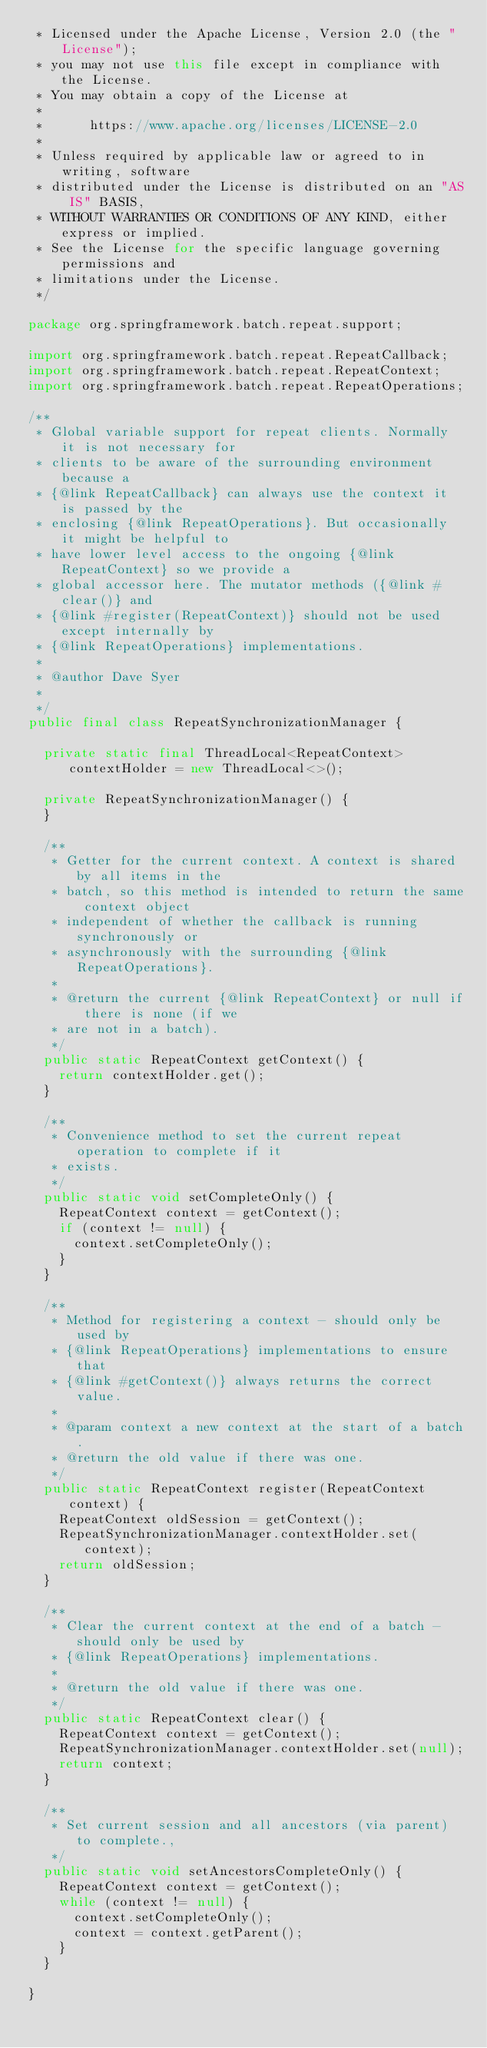Convert code to text. <code><loc_0><loc_0><loc_500><loc_500><_Java_> * Licensed under the Apache License, Version 2.0 (the "License");
 * you may not use this file except in compliance with the License.
 * You may obtain a copy of the License at
 *
 *      https://www.apache.org/licenses/LICENSE-2.0
 *
 * Unless required by applicable law or agreed to in writing, software
 * distributed under the License is distributed on an "AS IS" BASIS,
 * WITHOUT WARRANTIES OR CONDITIONS OF ANY KIND, either express or implied.
 * See the License for the specific language governing permissions and
 * limitations under the License.
 */

package org.springframework.batch.repeat.support;

import org.springframework.batch.repeat.RepeatCallback;
import org.springframework.batch.repeat.RepeatContext;
import org.springframework.batch.repeat.RepeatOperations;

/**
 * Global variable support for repeat clients. Normally it is not necessary for
 * clients to be aware of the surrounding environment because a
 * {@link RepeatCallback} can always use the context it is passed by the
 * enclosing {@link RepeatOperations}. But occasionally it might be helpful to
 * have lower level access to the ongoing {@link RepeatContext} so we provide a
 * global accessor here. The mutator methods ({@link #clear()} and
 * {@link #register(RepeatContext)} should not be used except internally by
 * {@link RepeatOperations} implementations.
 * 
 * @author Dave Syer
 * 
 */
public final class RepeatSynchronizationManager {

	private static final ThreadLocal<RepeatContext> contextHolder = new ThreadLocal<>();

	private RepeatSynchronizationManager() {
	}

	/**
	 * Getter for the current context. A context is shared by all items in the
	 * batch, so this method is intended to return the same context object
	 * independent of whether the callback is running synchronously or
	 * asynchronously with the surrounding {@link RepeatOperations}.
	 * 
	 * @return the current {@link RepeatContext} or null if there is none (if we
	 * are not in a batch).
	 */
	public static RepeatContext getContext() {
		return contextHolder.get();
	}

	/**
	 * Convenience method to set the current repeat operation to complete if it
	 * exists.
	 */
	public static void setCompleteOnly() {
		RepeatContext context = getContext();
		if (context != null) {
			context.setCompleteOnly();
		}
	}

	/**
	 * Method for registering a context - should only be used by
	 * {@link RepeatOperations} implementations to ensure that
	 * {@link #getContext()} always returns the correct value.
	 * 
	 * @param context a new context at the start of a batch.
	 * @return the old value if there was one.
	 */
	public static RepeatContext register(RepeatContext context) {
		RepeatContext oldSession = getContext();
		RepeatSynchronizationManager.contextHolder.set(context);
		return oldSession;
	}

	/**
	 * Clear the current context at the end of a batch - should only be used by
	 * {@link RepeatOperations} implementations.
	 * 
	 * @return the old value if there was one.
	 */
	public static RepeatContext clear() {
		RepeatContext context = getContext();
		RepeatSynchronizationManager.contextHolder.set(null);
		return context;
	}

	/**
	 * Set current session and all ancestors (via parent) to complete.,
	 */
	public static void setAncestorsCompleteOnly() {
		RepeatContext context = getContext();
		while (context != null) {
			context.setCompleteOnly();
			context = context.getParent();
		}
	}

}
</code> 